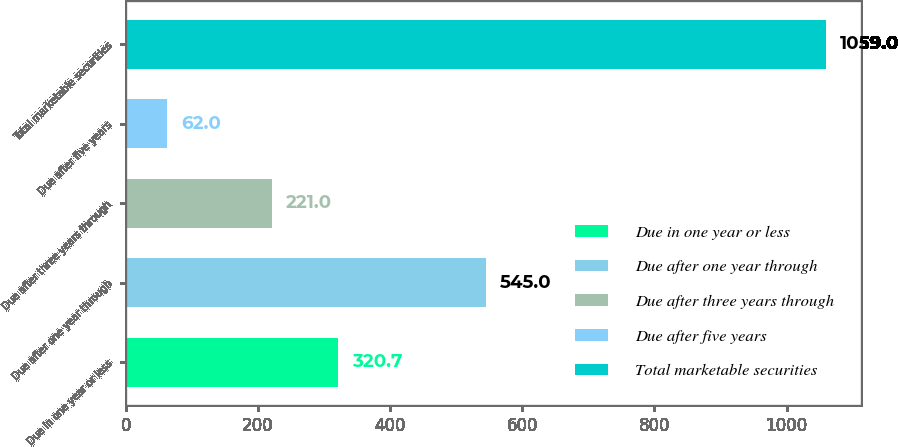Convert chart. <chart><loc_0><loc_0><loc_500><loc_500><bar_chart><fcel>Due in one year or less<fcel>Due after one year through<fcel>Due after three years through<fcel>Due after five years<fcel>Total marketable securities<nl><fcel>320.7<fcel>545<fcel>221<fcel>62<fcel>1059<nl></chart> 